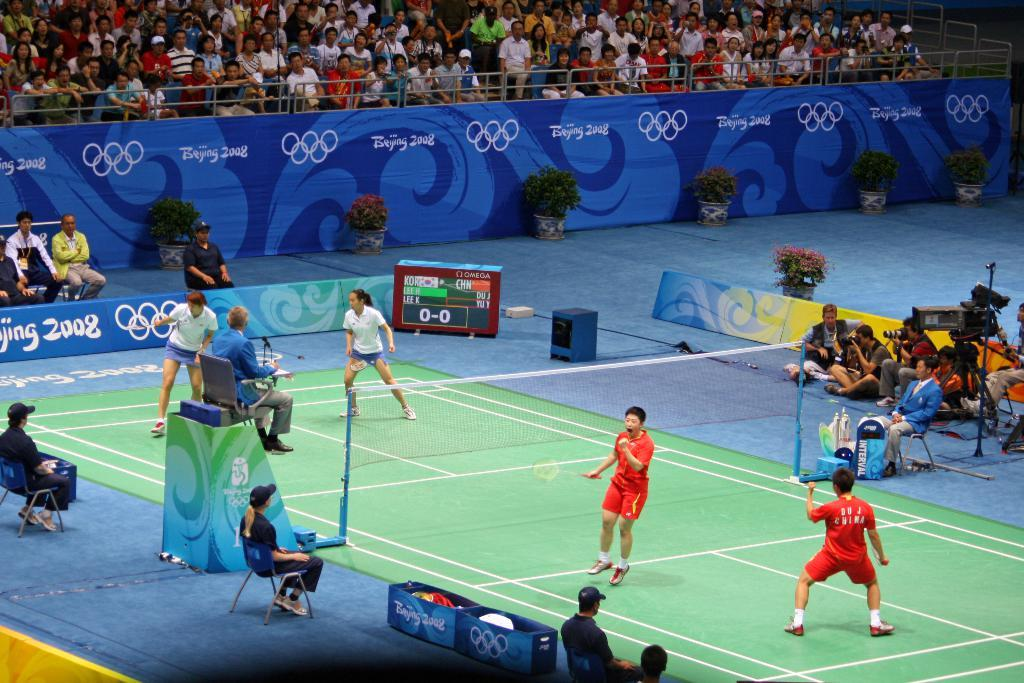Provide a one-sentence caption for the provided image. A group of people playing tennis in the olympics in 2008. 